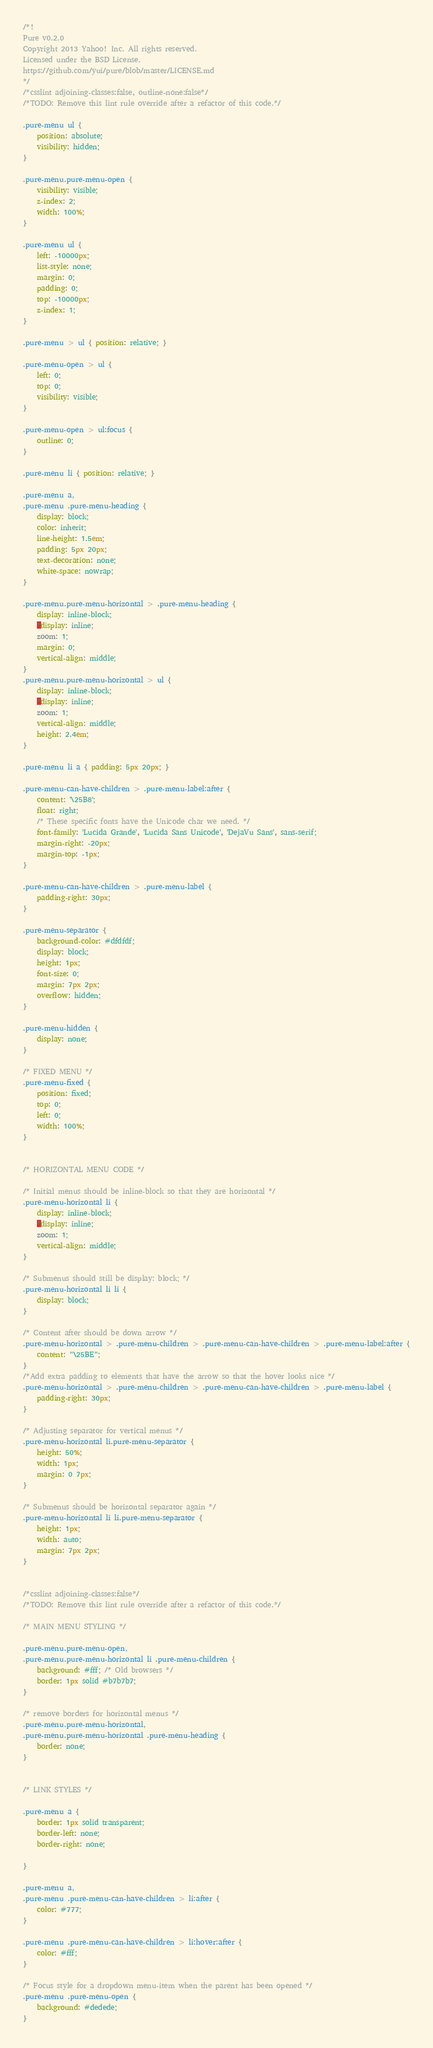Convert code to text. <code><loc_0><loc_0><loc_500><loc_500><_CSS_>/*!
Pure v0.2.0
Copyright 2013 Yahoo! Inc. All rights reserved.
Licensed under the BSD License.
https://github.com/yui/pure/blob/master/LICENSE.md
*/
/*csslint adjoining-classes:false, outline-none:false*/
/*TODO: Remove this lint rule override after a refactor of this code.*/

.pure-menu ul {
    position: absolute;
    visibility: hidden;
}

.pure-menu.pure-menu-open {
    visibility: visible;
    z-index: 2;
    width: 100%;
}

.pure-menu ul {
    left: -10000px;
    list-style: none;
    margin: 0;
    padding: 0;
    top: -10000px;
    z-index: 1;
}

.pure-menu > ul { position: relative; }

.pure-menu-open > ul {
    left: 0;
    top: 0;
    visibility: visible;
}

.pure-menu-open > ul:focus {
    outline: 0;
}

.pure-menu li { position: relative; }

.pure-menu a,
.pure-menu .pure-menu-heading {
    display: block;
    color: inherit;
    line-height: 1.5em;
    padding: 5px 20px;
    text-decoration: none;
    white-space: nowrap;
}

.pure-menu.pure-menu-horizontal > .pure-menu-heading {
    display: inline-block;
    *display: inline;
    zoom: 1;
    margin: 0;
    vertical-align: middle;
}
.pure-menu.pure-menu-horizontal > ul {
    display: inline-block;
    *display: inline;
    zoom: 1;
    vertical-align: middle;
    height: 2.4em;
}

.pure-menu li a { padding: 5px 20px; }

.pure-menu-can-have-children > .pure-menu-label:after {
    content: '\25B8';
    float: right;
    /* These specific fonts have the Unicode char we need. */
    font-family: 'Lucida Grande', 'Lucida Sans Unicode', 'DejaVu Sans', sans-serif;
    margin-right: -20px;
    margin-top: -1px;
}

.pure-menu-can-have-children > .pure-menu-label {
    padding-right: 30px;
}

.pure-menu-separator {
    background-color: #dfdfdf;
    display: block;
    height: 1px;
    font-size: 0;
    margin: 7px 2px;
    overflow: hidden;
}

.pure-menu-hidden {
    display: none;
}

/* FIXED MENU */
.pure-menu-fixed {
    position: fixed;
    top: 0;
    left: 0;
    width: 100%;
}


/* HORIZONTAL MENU CODE */

/* Initial menus should be inline-block so that they are horizontal */
.pure-menu-horizontal li {
    display: inline-block;
    *display: inline;
    zoom: 1;
    vertical-align: middle;
}

/* Submenus should still be display: block; */
.pure-menu-horizontal li li {
    display: block;
}

/* Content after should be down arrow */
.pure-menu-horizontal > .pure-menu-children > .pure-menu-can-have-children > .pure-menu-label:after {
    content: "\25BE";
}
/*Add extra padding to elements that have the arrow so that the hover looks nice */
.pure-menu-horizontal > .pure-menu-children > .pure-menu-can-have-children > .pure-menu-label {
    padding-right: 30px;
}

/* Adjusting separator for vertical menus */
.pure-menu-horizontal li.pure-menu-separator {
	height: 50%;
	width: 1px;
	margin: 0 7px;
}

/* Submenus should be horizontal separator again */
.pure-menu-horizontal li li.pure-menu-separator {
	height: 1px;
	width: auto;
	margin: 7px 2px;
}


/*csslint adjoining-classes:false*/
/*TODO: Remove this lint rule override after a refactor of this code.*/

/* MAIN MENU STYLING */

.pure-menu.pure-menu-open,
.pure-menu.pure-menu-horizontal li .pure-menu-children {
    background: #fff; /* Old browsers */
    border: 1px solid #b7b7b7;
}

/* remove borders for horizontal menus */
.pure-menu.pure-menu-horizontal,
.pure-menu.pure-menu-horizontal .pure-menu-heading {
    border: none;
}


/* LINK STYLES */

.pure-menu a {
    border: 1px solid transparent;
    border-left: none;
    border-right: none;

}

.pure-menu a,
.pure-menu .pure-menu-can-have-children > li:after {
    color: #777;
}

.pure-menu .pure-menu-can-have-children > li:hover:after {
    color: #fff;
}

/* Focus style for a dropdown menu-item when the parent has been opened */
.pure-menu .pure-menu-open {
    background: #dedede;
}

</code> 